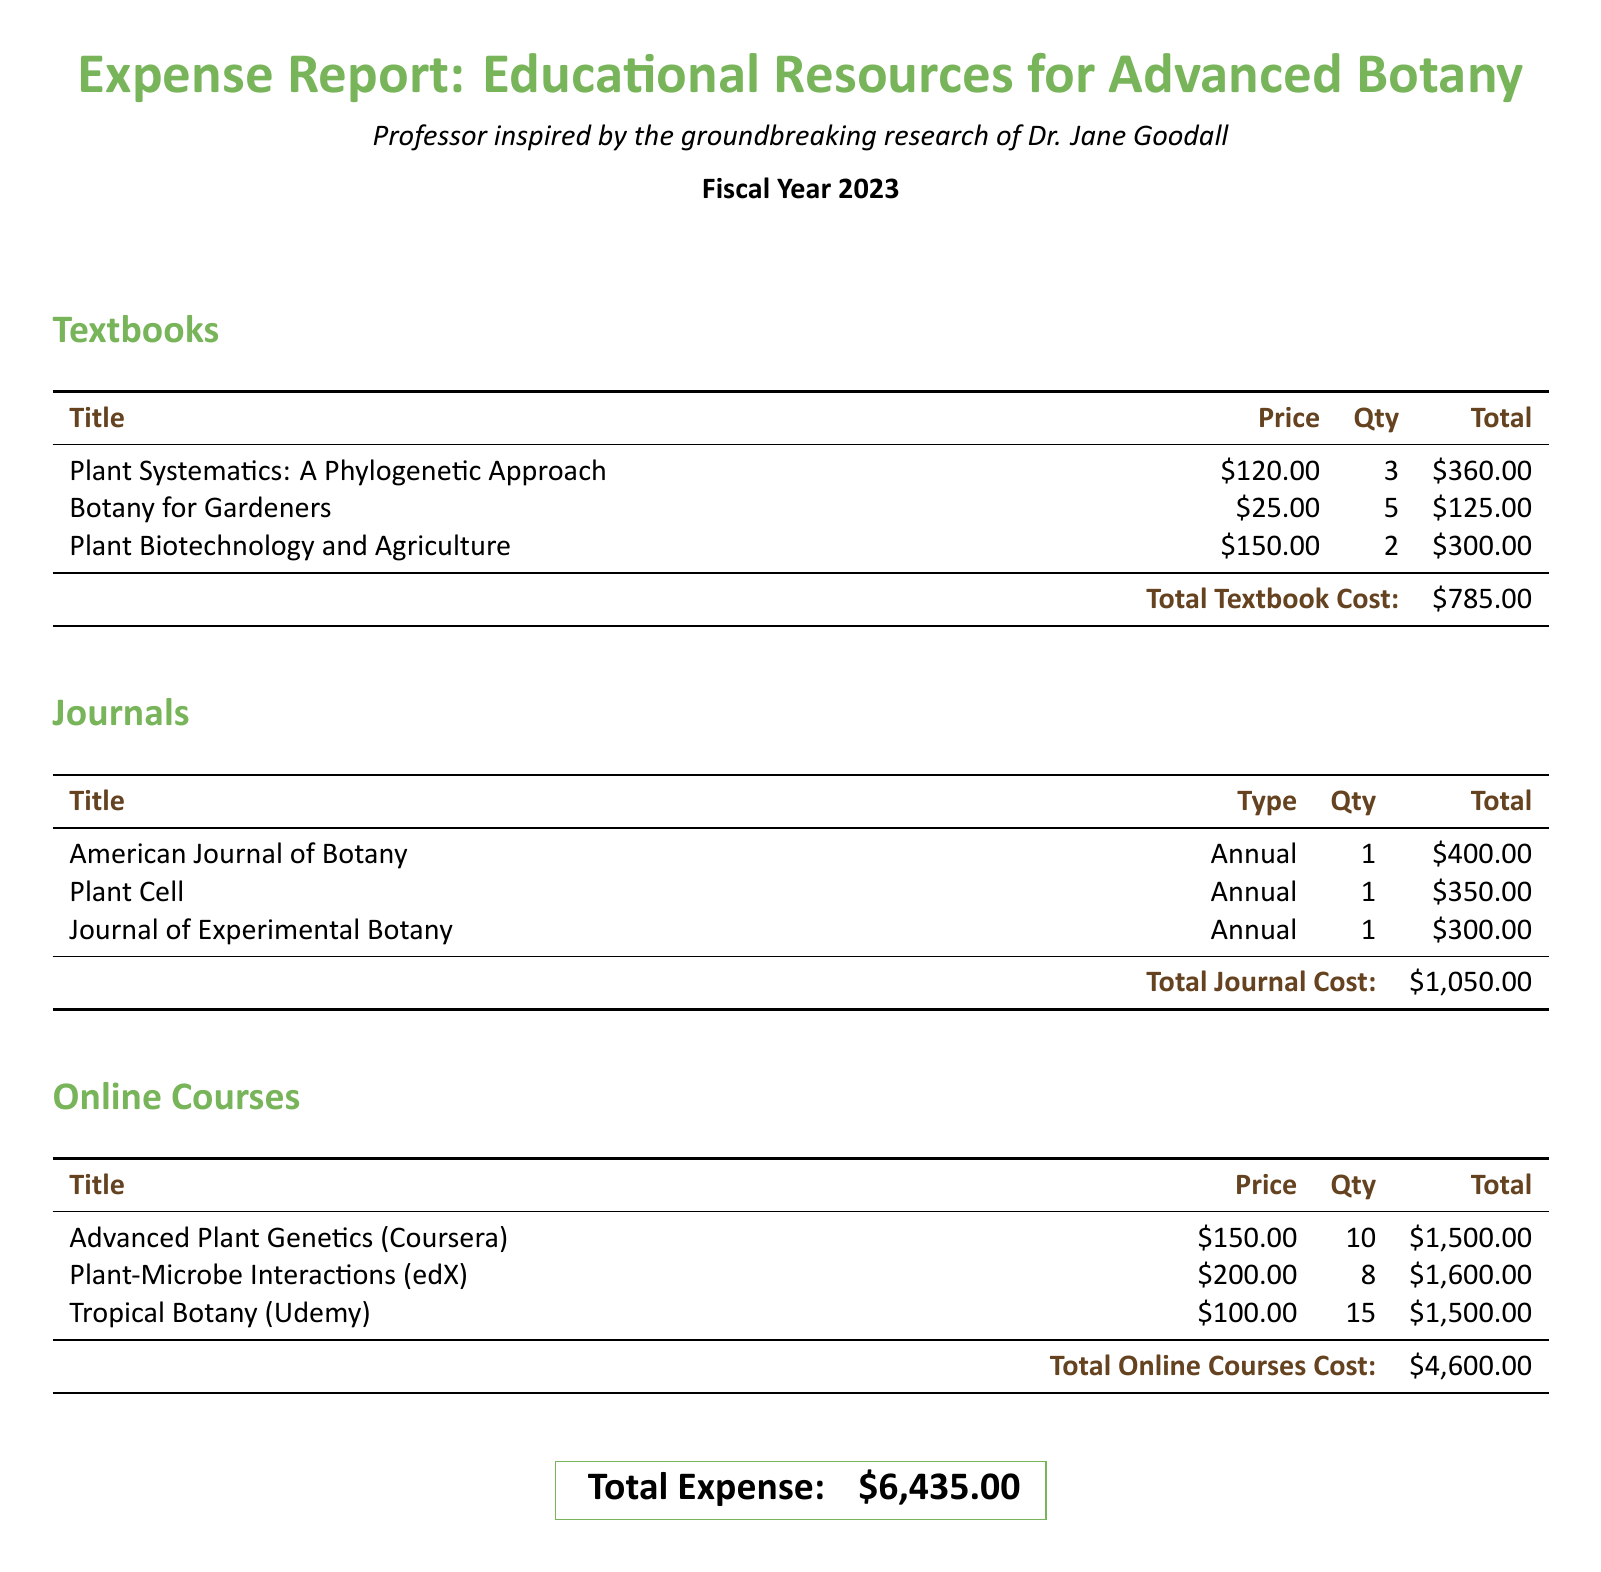What is the total cost of textbooks? The total cost of textbooks is provided at the bottom of the textbook section, which summarizes the total price for all textbooks listed.
Answer: $785.00 How many copies of "Botany for Gardeners" were purchased? The quantity for "Botany for Gardeners" is specified in the textbook section, showing how many copies were bought.
Answer: 5 What is the price of "Advanced Plant Genetics"? The price is indicated next to the course title in the online courses section.
Answer: $150.00 What is the total expense reported for all educational resources? The total expense is given at the end of the document as a summary of all costs incurred across different categories.
Answer: $6,435.00 Which journal costs $300 annually? The journal with this annual cost is listed in the journals section, indicating its total price and type.
Answer: Journal of Experimental Botany How many online courses were listed in total? The number of courses can be determined by counting the listed titles in the online courses section.
Answer: 3 What is the total cost for all journals? The total cost of journals is summarized at the bottom of the journals section, combining all individual journal costs.
Answer: $1,050.00 Which online course has the highest total cost? To find this, we compare the total costs of all online courses listed.
Answer: Plant-Microbe Interactions What is the price of "Plant Cell"? This price is specifically mentioned next to the journal title in the journals section, providing its annual cost.
Answer: $350.00 